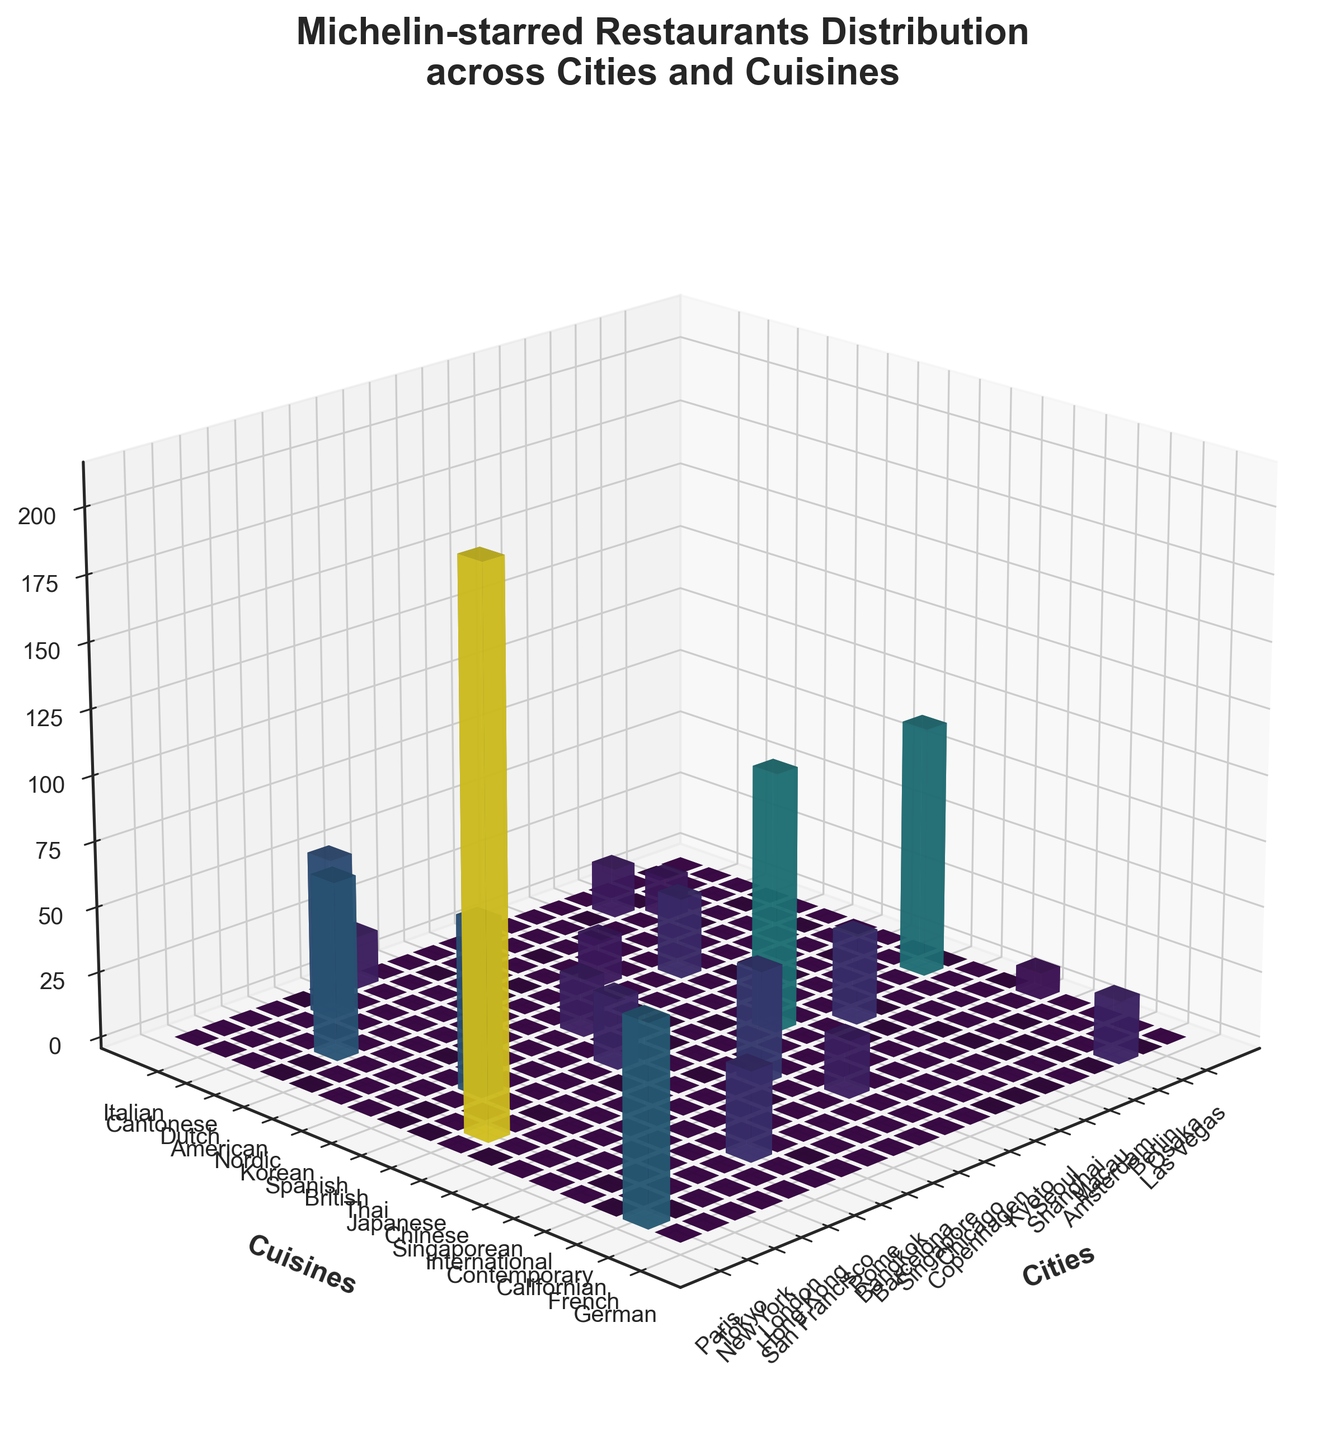what is the title of the figure? The title of the figure is displayed at the top of the plot. It is written in a slightly larger and bolder font compared to the other text in the figure.
Answer: Michelin-starred Restaurants Distribution across Cities and Cuisines Which city has the highest number of Michelin stars? To find out which city has the highest number of Michelin stars, look at the bars' heights in the 3D bar plot. The tallest bar will correspond to the city with the highest number of Michelin stars.
Answer: Tokyo How many Michelin stars are awarded for French cuisine in Paris? Locate the city of "Paris" on the x-axis and then find the bar corresponding to "French" cuisine on the y-axis. The height of this bar gives the Michelin stars.
Answer: 75 What are the two cuisines with the highest number of Michelin stars in Tokyo? Find Tokyo on the x-axis and observe the bars raised from this location. The two tallest bars from this point correspond to the cuisines with the most Michelin stars.
Answer: Japanese, French Compare the total Michelin stars between New York and London. Which city has more, and by how many? Find the bars corresponding to New York and London on the x-axis. Sum the heights of all bars for each city and then compare these sums. The difference gives the number.
Answer: New York has 2 more than London What is the average number of Michelin stars across all cuisine categories in Hong Kong? Find "Hong Kong" on the x-axis and identify all the bars representing different cuisines for Hong Kong. Sum up the heights of these bars and divide by the number of bars (cuisines).
Answer: 61 Which cuisine is represented in the most cities? Check along the y-axis for each cuisine category and count the number of distinct bars representing cities within each cuisine. The cuisine with the most counts is the answer.
Answer: Japanese How many cities have Michelin stars for Cantonese cuisine? Find the bars corresponding to "Cantonese" on the y-axis and count the number of these bars extending from various cities.
Answer: 2 What is the total number of Michelin stars awarded to Japanese cuisine across all cities? Identify all bars representing Japanese cuisine by looking along the y-axis. Sum the heights of these bars corresponding to all cities.
Answer: 407 Which city has the lowest number of Michelin stars for International cuisine? Look for the "International" category on the y-axis and identify the cities represented by this cuisine. The city with the shortest bar has the lowest number of Michelin stars.
Answer: Las Vegas 